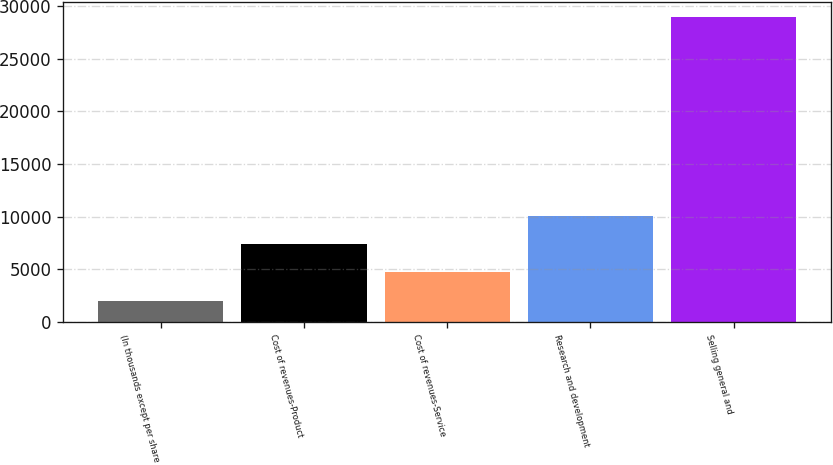<chart> <loc_0><loc_0><loc_500><loc_500><bar_chart><fcel>(In thousands except per share<fcel>Cost of revenues-Product<fcel>Cost of revenues-Service<fcel>Research and development<fcel>Selling general and<nl><fcel>2009<fcel>7404.2<fcel>4706.6<fcel>10101.8<fcel>28985<nl></chart> 